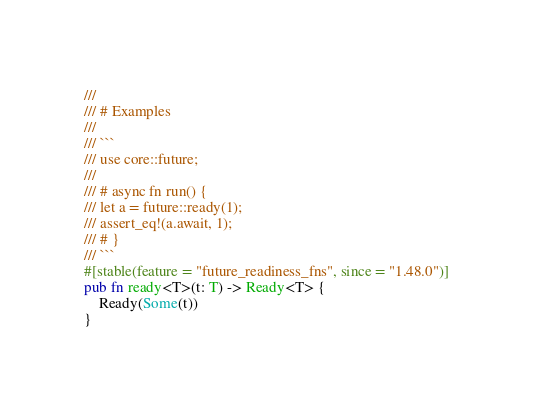Convert code to text. <code><loc_0><loc_0><loc_500><loc_500><_Rust_>///
/// # Examples
///
/// ```
/// use core::future;
///
/// # async fn run() {
/// let a = future::ready(1);
/// assert_eq!(a.await, 1);
/// # }
/// ```
#[stable(feature = "future_readiness_fns", since = "1.48.0")]
pub fn ready<T>(t: T) -> Ready<T> {
    Ready(Some(t))
}
</code> 